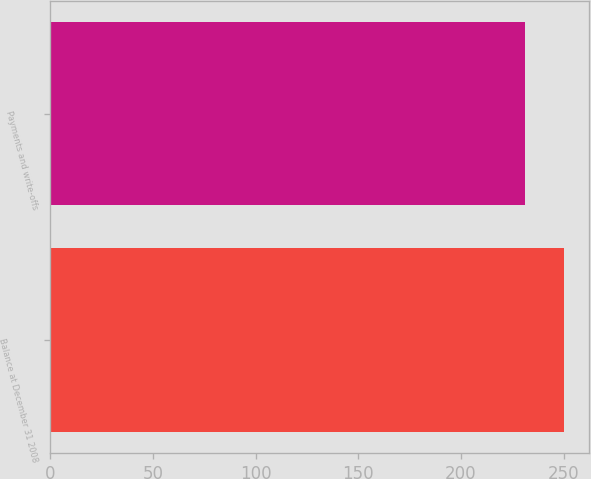Convert chart. <chart><loc_0><loc_0><loc_500><loc_500><bar_chart><fcel>Balance at December 31 2008<fcel>Payments and write-offs<nl><fcel>250<fcel>231<nl></chart> 